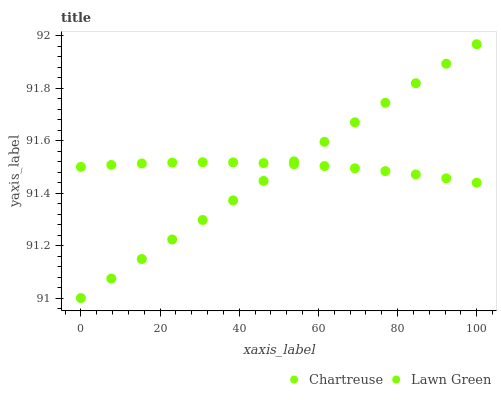Does Lawn Green have the minimum area under the curve?
Answer yes or no. Yes. Does Chartreuse have the maximum area under the curve?
Answer yes or no. Yes. Does Chartreuse have the minimum area under the curve?
Answer yes or no. No. Is Lawn Green the smoothest?
Answer yes or no. Yes. Is Chartreuse the roughest?
Answer yes or no. Yes. Is Chartreuse the smoothest?
Answer yes or no. No. Does Lawn Green have the lowest value?
Answer yes or no. Yes. Does Chartreuse have the lowest value?
Answer yes or no. No. Does Lawn Green have the highest value?
Answer yes or no. Yes. Does Chartreuse have the highest value?
Answer yes or no. No. Does Lawn Green intersect Chartreuse?
Answer yes or no. Yes. Is Lawn Green less than Chartreuse?
Answer yes or no. No. Is Lawn Green greater than Chartreuse?
Answer yes or no. No. 